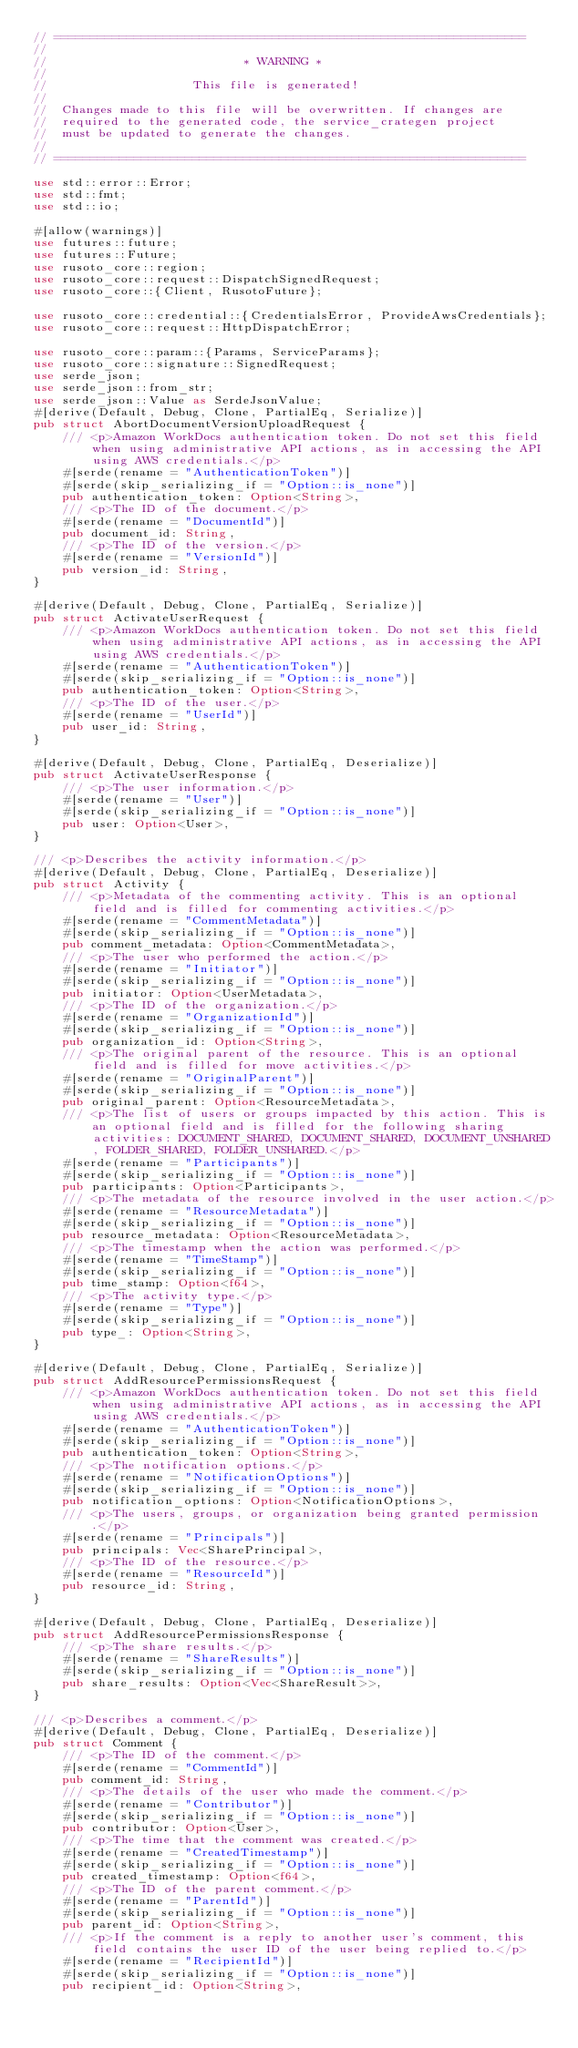<code> <loc_0><loc_0><loc_500><loc_500><_Rust_>// =================================================================
//
//                           * WARNING *
//
//                    This file is generated!
//
//  Changes made to this file will be overwritten. If changes are
//  required to the generated code, the service_crategen project
//  must be updated to generate the changes.
//
// =================================================================

use std::error::Error;
use std::fmt;
use std::io;

#[allow(warnings)]
use futures::future;
use futures::Future;
use rusoto_core::region;
use rusoto_core::request::DispatchSignedRequest;
use rusoto_core::{Client, RusotoFuture};

use rusoto_core::credential::{CredentialsError, ProvideAwsCredentials};
use rusoto_core::request::HttpDispatchError;

use rusoto_core::param::{Params, ServiceParams};
use rusoto_core::signature::SignedRequest;
use serde_json;
use serde_json::from_str;
use serde_json::Value as SerdeJsonValue;
#[derive(Default, Debug, Clone, PartialEq, Serialize)]
pub struct AbortDocumentVersionUploadRequest {
    /// <p>Amazon WorkDocs authentication token. Do not set this field when using administrative API actions, as in accessing the API using AWS credentials.</p>
    #[serde(rename = "AuthenticationToken")]
    #[serde(skip_serializing_if = "Option::is_none")]
    pub authentication_token: Option<String>,
    /// <p>The ID of the document.</p>
    #[serde(rename = "DocumentId")]
    pub document_id: String,
    /// <p>The ID of the version.</p>
    #[serde(rename = "VersionId")]
    pub version_id: String,
}

#[derive(Default, Debug, Clone, PartialEq, Serialize)]
pub struct ActivateUserRequest {
    /// <p>Amazon WorkDocs authentication token. Do not set this field when using administrative API actions, as in accessing the API using AWS credentials.</p>
    #[serde(rename = "AuthenticationToken")]
    #[serde(skip_serializing_if = "Option::is_none")]
    pub authentication_token: Option<String>,
    /// <p>The ID of the user.</p>
    #[serde(rename = "UserId")]
    pub user_id: String,
}

#[derive(Default, Debug, Clone, PartialEq, Deserialize)]
pub struct ActivateUserResponse {
    /// <p>The user information.</p>
    #[serde(rename = "User")]
    #[serde(skip_serializing_if = "Option::is_none")]
    pub user: Option<User>,
}

/// <p>Describes the activity information.</p>
#[derive(Default, Debug, Clone, PartialEq, Deserialize)]
pub struct Activity {
    /// <p>Metadata of the commenting activity. This is an optional field and is filled for commenting activities.</p>
    #[serde(rename = "CommentMetadata")]
    #[serde(skip_serializing_if = "Option::is_none")]
    pub comment_metadata: Option<CommentMetadata>,
    /// <p>The user who performed the action.</p>
    #[serde(rename = "Initiator")]
    #[serde(skip_serializing_if = "Option::is_none")]
    pub initiator: Option<UserMetadata>,
    /// <p>The ID of the organization.</p>
    #[serde(rename = "OrganizationId")]
    #[serde(skip_serializing_if = "Option::is_none")]
    pub organization_id: Option<String>,
    /// <p>The original parent of the resource. This is an optional field and is filled for move activities.</p>
    #[serde(rename = "OriginalParent")]
    #[serde(skip_serializing_if = "Option::is_none")]
    pub original_parent: Option<ResourceMetadata>,
    /// <p>The list of users or groups impacted by this action. This is an optional field and is filled for the following sharing activities: DOCUMENT_SHARED, DOCUMENT_SHARED, DOCUMENT_UNSHARED, FOLDER_SHARED, FOLDER_UNSHARED.</p>
    #[serde(rename = "Participants")]
    #[serde(skip_serializing_if = "Option::is_none")]
    pub participants: Option<Participants>,
    /// <p>The metadata of the resource involved in the user action.</p>
    #[serde(rename = "ResourceMetadata")]
    #[serde(skip_serializing_if = "Option::is_none")]
    pub resource_metadata: Option<ResourceMetadata>,
    /// <p>The timestamp when the action was performed.</p>
    #[serde(rename = "TimeStamp")]
    #[serde(skip_serializing_if = "Option::is_none")]
    pub time_stamp: Option<f64>,
    /// <p>The activity type.</p>
    #[serde(rename = "Type")]
    #[serde(skip_serializing_if = "Option::is_none")]
    pub type_: Option<String>,
}

#[derive(Default, Debug, Clone, PartialEq, Serialize)]
pub struct AddResourcePermissionsRequest {
    /// <p>Amazon WorkDocs authentication token. Do not set this field when using administrative API actions, as in accessing the API using AWS credentials.</p>
    #[serde(rename = "AuthenticationToken")]
    #[serde(skip_serializing_if = "Option::is_none")]
    pub authentication_token: Option<String>,
    /// <p>The notification options.</p>
    #[serde(rename = "NotificationOptions")]
    #[serde(skip_serializing_if = "Option::is_none")]
    pub notification_options: Option<NotificationOptions>,
    /// <p>The users, groups, or organization being granted permission.</p>
    #[serde(rename = "Principals")]
    pub principals: Vec<SharePrincipal>,
    /// <p>The ID of the resource.</p>
    #[serde(rename = "ResourceId")]
    pub resource_id: String,
}

#[derive(Default, Debug, Clone, PartialEq, Deserialize)]
pub struct AddResourcePermissionsResponse {
    /// <p>The share results.</p>
    #[serde(rename = "ShareResults")]
    #[serde(skip_serializing_if = "Option::is_none")]
    pub share_results: Option<Vec<ShareResult>>,
}

/// <p>Describes a comment.</p>
#[derive(Default, Debug, Clone, PartialEq, Deserialize)]
pub struct Comment {
    /// <p>The ID of the comment.</p>
    #[serde(rename = "CommentId")]
    pub comment_id: String,
    /// <p>The details of the user who made the comment.</p>
    #[serde(rename = "Contributor")]
    #[serde(skip_serializing_if = "Option::is_none")]
    pub contributor: Option<User>,
    /// <p>The time that the comment was created.</p>
    #[serde(rename = "CreatedTimestamp")]
    #[serde(skip_serializing_if = "Option::is_none")]
    pub created_timestamp: Option<f64>,
    /// <p>The ID of the parent comment.</p>
    #[serde(rename = "ParentId")]
    #[serde(skip_serializing_if = "Option::is_none")]
    pub parent_id: Option<String>,
    /// <p>If the comment is a reply to another user's comment, this field contains the user ID of the user being replied to.</p>
    #[serde(rename = "RecipientId")]
    #[serde(skip_serializing_if = "Option::is_none")]
    pub recipient_id: Option<String>,</code> 